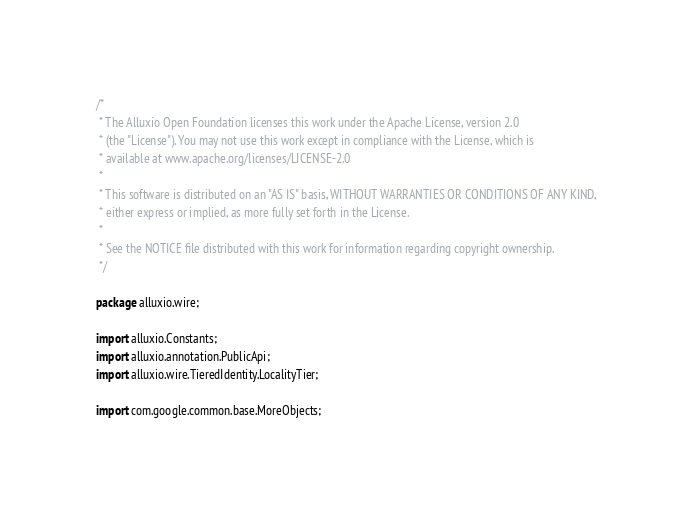<code> <loc_0><loc_0><loc_500><loc_500><_Java_>/*
 * The Alluxio Open Foundation licenses this work under the Apache License, version 2.0
 * (the "License"). You may not use this work except in compliance with the License, which is
 * available at www.apache.org/licenses/LICENSE-2.0
 *
 * This software is distributed on an "AS IS" basis, WITHOUT WARRANTIES OR CONDITIONS OF ANY KIND,
 * either express or implied, as more fully set forth in the License.
 *
 * See the NOTICE file distributed with this work for information regarding copyright ownership.
 */

package alluxio.wire;

import alluxio.Constants;
import alluxio.annotation.PublicApi;
import alluxio.wire.TieredIdentity.LocalityTier;

import com.google.common.base.MoreObjects;</code> 